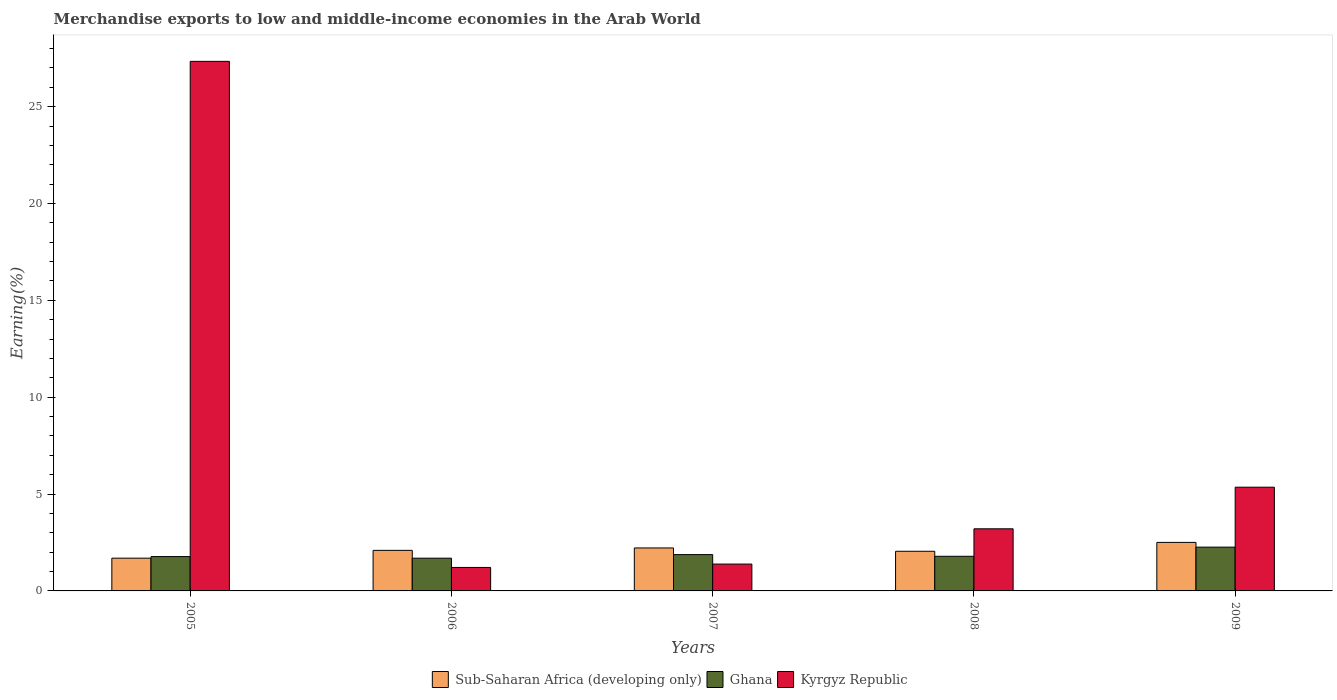How many different coloured bars are there?
Offer a terse response. 3. Are the number of bars per tick equal to the number of legend labels?
Offer a very short reply. Yes. Are the number of bars on each tick of the X-axis equal?
Give a very brief answer. Yes. How many bars are there on the 2nd tick from the left?
Your answer should be compact. 3. What is the percentage of amount earned from merchandise exports in Kyrgyz Republic in 2008?
Provide a succinct answer. 3.21. Across all years, what is the maximum percentage of amount earned from merchandise exports in Ghana?
Provide a succinct answer. 2.26. Across all years, what is the minimum percentage of amount earned from merchandise exports in Kyrgyz Republic?
Keep it short and to the point. 1.21. In which year was the percentage of amount earned from merchandise exports in Kyrgyz Republic maximum?
Your answer should be very brief. 2005. In which year was the percentage of amount earned from merchandise exports in Kyrgyz Republic minimum?
Offer a very short reply. 2006. What is the total percentage of amount earned from merchandise exports in Sub-Saharan Africa (developing only) in the graph?
Provide a succinct answer. 10.56. What is the difference between the percentage of amount earned from merchandise exports in Kyrgyz Republic in 2007 and that in 2009?
Your response must be concise. -3.97. What is the difference between the percentage of amount earned from merchandise exports in Sub-Saharan Africa (developing only) in 2008 and the percentage of amount earned from merchandise exports in Kyrgyz Republic in 2005?
Your answer should be compact. -25.29. What is the average percentage of amount earned from merchandise exports in Sub-Saharan Africa (developing only) per year?
Provide a short and direct response. 2.11. In the year 2006, what is the difference between the percentage of amount earned from merchandise exports in Sub-Saharan Africa (developing only) and percentage of amount earned from merchandise exports in Ghana?
Offer a terse response. 0.4. In how many years, is the percentage of amount earned from merchandise exports in Sub-Saharan Africa (developing only) greater than 8 %?
Provide a succinct answer. 0. What is the ratio of the percentage of amount earned from merchandise exports in Sub-Saharan Africa (developing only) in 2007 to that in 2009?
Offer a very short reply. 0.89. Is the difference between the percentage of amount earned from merchandise exports in Sub-Saharan Africa (developing only) in 2008 and 2009 greater than the difference between the percentage of amount earned from merchandise exports in Ghana in 2008 and 2009?
Your answer should be very brief. Yes. What is the difference between the highest and the second highest percentage of amount earned from merchandise exports in Ghana?
Keep it short and to the point. 0.39. What is the difference between the highest and the lowest percentage of amount earned from merchandise exports in Ghana?
Make the answer very short. 0.57. What does the 3rd bar from the left in 2006 represents?
Your answer should be very brief. Kyrgyz Republic. What does the 1st bar from the right in 2005 represents?
Offer a very short reply. Kyrgyz Republic. How many bars are there?
Ensure brevity in your answer.  15. Does the graph contain any zero values?
Provide a short and direct response. No. Does the graph contain grids?
Provide a succinct answer. No. Where does the legend appear in the graph?
Keep it short and to the point. Bottom center. How many legend labels are there?
Ensure brevity in your answer.  3. How are the legend labels stacked?
Offer a terse response. Horizontal. What is the title of the graph?
Your response must be concise. Merchandise exports to low and middle-income economies in the Arab World. What is the label or title of the X-axis?
Give a very brief answer. Years. What is the label or title of the Y-axis?
Offer a terse response. Earning(%). What is the Earning(%) of Sub-Saharan Africa (developing only) in 2005?
Offer a terse response. 1.69. What is the Earning(%) of Ghana in 2005?
Your answer should be compact. 1.77. What is the Earning(%) of Kyrgyz Republic in 2005?
Provide a succinct answer. 27.34. What is the Earning(%) of Sub-Saharan Africa (developing only) in 2006?
Offer a terse response. 2.09. What is the Earning(%) in Ghana in 2006?
Give a very brief answer. 1.69. What is the Earning(%) in Kyrgyz Republic in 2006?
Offer a very short reply. 1.21. What is the Earning(%) of Sub-Saharan Africa (developing only) in 2007?
Ensure brevity in your answer.  2.22. What is the Earning(%) in Ghana in 2007?
Offer a very short reply. 1.87. What is the Earning(%) of Kyrgyz Republic in 2007?
Provide a succinct answer. 1.39. What is the Earning(%) of Sub-Saharan Africa (developing only) in 2008?
Offer a terse response. 2.05. What is the Earning(%) in Ghana in 2008?
Provide a succinct answer. 1.79. What is the Earning(%) in Kyrgyz Republic in 2008?
Give a very brief answer. 3.21. What is the Earning(%) of Sub-Saharan Africa (developing only) in 2009?
Offer a very short reply. 2.51. What is the Earning(%) of Ghana in 2009?
Make the answer very short. 2.26. What is the Earning(%) of Kyrgyz Republic in 2009?
Your answer should be compact. 5.35. Across all years, what is the maximum Earning(%) in Sub-Saharan Africa (developing only)?
Provide a short and direct response. 2.51. Across all years, what is the maximum Earning(%) in Ghana?
Ensure brevity in your answer.  2.26. Across all years, what is the maximum Earning(%) of Kyrgyz Republic?
Provide a short and direct response. 27.34. Across all years, what is the minimum Earning(%) in Sub-Saharan Africa (developing only)?
Offer a terse response. 1.69. Across all years, what is the minimum Earning(%) of Ghana?
Make the answer very short. 1.69. Across all years, what is the minimum Earning(%) in Kyrgyz Republic?
Your response must be concise. 1.21. What is the total Earning(%) in Sub-Saharan Africa (developing only) in the graph?
Provide a short and direct response. 10.56. What is the total Earning(%) of Ghana in the graph?
Ensure brevity in your answer.  9.39. What is the total Earning(%) of Kyrgyz Republic in the graph?
Offer a terse response. 38.5. What is the difference between the Earning(%) in Sub-Saharan Africa (developing only) in 2005 and that in 2006?
Your response must be concise. -0.4. What is the difference between the Earning(%) in Ghana in 2005 and that in 2006?
Offer a very short reply. 0.08. What is the difference between the Earning(%) in Kyrgyz Republic in 2005 and that in 2006?
Ensure brevity in your answer.  26.13. What is the difference between the Earning(%) in Sub-Saharan Africa (developing only) in 2005 and that in 2007?
Keep it short and to the point. -0.53. What is the difference between the Earning(%) of Ghana in 2005 and that in 2007?
Offer a terse response. -0.1. What is the difference between the Earning(%) of Kyrgyz Republic in 2005 and that in 2007?
Provide a succinct answer. 25.95. What is the difference between the Earning(%) of Sub-Saharan Africa (developing only) in 2005 and that in 2008?
Your answer should be compact. -0.36. What is the difference between the Earning(%) in Ghana in 2005 and that in 2008?
Provide a short and direct response. -0.01. What is the difference between the Earning(%) of Kyrgyz Republic in 2005 and that in 2008?
Give a very brief answer. 24.13. What is the difference between the Earning(%) of Sub-Saharan Africa (developing only) in 2005 and that in 2009?
Provide a short and direct response. -0.81. What is the difference between the Earning(%) of Ghana in 2005 and that in 2009?
Make the answer very short. -0.49. What is the difference between the Earning(%) in Kyrgyz Republic in 2005 and that in 2009?
Offer a terse response. 21.98. What is the difference between the Earning(%) in Sub-Saharan Africa (developing only) in 2006 and that in 2007?
Your answer should be very brief. -0.13. What is the difference between the Earning(%) of Ghana in 2006 and that in 2007?
Offer a terse response. -0.18. What is the difference between the Earning(%) in Kyrgyz Republic in 2006 and that in 2007?
Provide a succinct answer. -0.17. What is the difference between the Earning(%) of Sub-Saharan Africa (developing only) in 2006 and that in 2008?
Keep it short and to the point. 0.05. What is the difference between the Earning(%) in Ghana in 2006 and that in 2008?
Give a very brief answer. -0.1. What is the difference between the Earning(%) in Kyrgyz Republic in 2006 and that in 2008?
Provide a succinct answer. -1.99. What is the difference between the Earning(%) in Sub-Saharan Africa (developing only) in 2006 and that in 2009?
Your answer should be compact. -0.41. What is the difference between the Earning(%) of Ghana in 2006 and that in 2009?
Give a very brief answer. -0.57. What is the difference between the Earning(%) in Kyrgyz Republic in 2006 and that in 2009?
Provide a succinct answer. -4.14. What is the difference between the Earning(%) of Sub-Saharan Africa (developing only) in 2007 and that in 2008?
Provide a short and direct response. 0.17. What is the difference between the Earning(%) of Ghana in 2007 and that in 2008?
Make the answer very short. 0.09. What is the difference between the Earning(%) in Kyrgyz Republic in 2007 and that in 2008?
Your answer should be compact. -1.82. What is the difference between the Earning(%) of Sub-Saharan Africa (developing only) in 2007 and that in 2009?
Provide a succinct answer. -0.29. What is the difference between the Earning(%) of Ghana in 2007 and that in 2009?
Provide a succinct answer. -0.39. What is the difference between the Earning(%) in Kyrgyz Republic in 2007 and that in 2009?
Your answer should be very brief. -3.97. What is the difference between the Earning(%) in Sub-Saharan Africa (developing only) in 2008 and that in 2009?
Keep it short and to the point. -0.46. What is the difference between the Earning(%) in Ghana in 2008 and that in 2009?
Keep it short and to the point. -0.47. What is the difference between the Earning(%) of Kyrgyz Republic in 2008 and that in 2009?
Give a very brief answer. -2.15. What is the difference between the Earning(%) of Sub-Saharan Africa (developing only) in 2005 and the Earning(%) of Ghana in 2006?
Ensure brevity in your answer.  0. What is the difference between the Earning(%) of Sub-Saharan Africa (developing only) in 2005 and the Earning(%) of Kyrgyz Republic in 2006?
Your answer should be compact. 0.48. What is the difference between the Earning(%) in Ghana in 2005 and the Earning(%) in Kyrgyz Republic in 2006?
Provide a short and direct response. 0.56. What is the difference between the Earning(%) in Sub-Saharan Africa (developing only) in 2005 and the Earning(%) in Ghana in 2007?
Keep it short and to the point. -0.18. What is the difference between the Earning(%) in Sub-Saharan Africa (developing only) in 2005 and the Earning(%) in Kyrgyz Republic in 2007?
Give a very brief answer. 0.31. What is the difference between the Earning(%) in Ghana in 2005 and the Earning(%) in Kyrgyz Republic in 2007?
Offer a very short reply. 0.39. What is the difference between the Earning(%) in Sub-Saharan Africa (developing only) in 2005 and the Earning(%) in Ghana in 2008?
Provide a succinct answer. -0.1. What is the difference between the Earning(%) in Sub-Saharan Africa (developing only) in 2005 and the Earning(%) in Kyrgyz Republic in 2008?
Provide a short and direct response. -1.52. What is the difference between the Earning(%) in Ghana in 2005 and the Earning(%) in Kyrgyz Republic in 2008?
Provide a succinct answer. -1.43. What is the difference between the Earning(%) in Sub-Saharan Africa (developing only) in 2005 and the Earning(%) in Ghana in 2009?
Provide a succinct answer. -0.57. What is the difference between the Earning(%) of Sub-Saharan Africa (developing only) in 2005 and the Earning(%) of Kyrgyz Republic in 2009?
Offer a very short reply. -3.66. What is the difference between the Earning(%) in Ghana in 2005 and the Earning(%) in Kyrgyz Republic in 2009?
Ensure brevity in your answer.  -3.58. What is the difference between the Earning(%) in Sub-Saharan Africa (developing only) in 2006 and the Earning(%) in Ghana in 2007?
Give a very brief answer. 0.22. What is the difference between the Earning(%) of Sub-Saharan Africa (developing only) in 2006 and the Earning(%) of Kyrgyz Republic in 2007?
Your answer should be very brief. 0.71. What is the difference between the Earning(%) in Ghana in 2006 and the Earning(%) in Kyrgyz Republic in 2007?
Your response must be concise. 0.3. What is the difference between the Earning(%) of Sub-Saharan Africa (developing only) in 2006 and the Earning(%) of Ghana in 2008?
Ensure brevity in your answer.  0.31. What is the difference between the Earning(%) of Sub-Saharan Africa (developing only) in 2006 and the Earning(%) of Kyrgyz Republic in 2008?
Offer a very short reply. -1.11. What is the difference between the Earning(%) of Ghana in 2006 and the Earning(%) of Kyrgyz Republic in 2008?
Provide a succinct answer. -1.52. What is the difference between the Earning(%) of Sub-Saharan Africa (developing only) in 2006 and the Earning(%) of Ghana in 2009?
Your response must be concise. -0.17. What is the difference between the Earning(%) of Sub-Saharan Africa (developing only) in 2006 and the Earning(%) of Kyrgyz Republic in 2009?
Ensure brevity in your answer.  -3.26. What is the difference between the Earning(%) of Ghana in 2006 and the Earning(%) of Kyrgyz Republic in 2009?
Make the answer very short. -3.66. What is the difference between the Earning(%) of Sub-Saharan Africa (developing only) in 2007 and the Earning(%) of Ghana in 2008?
Provide a succinct answer. 0.43. What is the difference between the Earning(%) in Sub-Saharan Africa (developing only) in 2007 and the Earning(%) in Kyrgyz Republic in 2008?
Provide a succinct answer. -0.99. What is the difference between the Earning(%) of Ghana in 2007 and the Earning(%) of Kyrgyz Republic in 2008?
Keep it short and to the point. -1.33. What is the difference between the Earning(%) in Sub-Saharan Africa (developing only) in 2007 and the Earning(%) in Ghana in 2009?
Give a very brief answer. -0.04. What is the difference between the Earning(%) in Sub-Saharan Africa (developing only) in 2007 and the Earning(%) in Kyrgyz Republic in 2009?
Provide a succinct answer. -3.14. What is the difference between the Earning(%) of Ghana in 2007 and the Earning(%) of Kyrgyz Republic in 2009?
Provide a succinct answer. -3.48. What is the difference between the Earning(%) in Sub-Saharan Africa (developing only) in 2008 and the Earning(%) in Ghana in 2009?
Offer a very short reply. -0.21. What is the difference between the Earning(%) of Sub-Saharan Africa (developing only) in 2008 and the Earning(%) of Kyrgyz Republic in 2009?
Provide a succinct answer. -3.31. What is the difference between the Earning(%) of Ghana in 2008 and the Earning(%) of Kyrgyz Republic in 2009?
Keep it short and to the point. -3.57. What is the average Earning(%) in Sub-Saharan Africa (developing only) per year?
Offer a very short reply. 2.11. What is the average Earning(%) of Ghana per year?
Offer a terse response. 1.88. What is the average Earning(%) in Kyrgyz Republic per year?
Your answer should be very brief. 7.7. In the year 2005, what is the difference between the Earning(%) in Sub-Saharan Africa (developing only) and Earning(%) in Ghana?
Your answer should be very brief. -0.08. In the year 2005, what is the difference between the Earning(%) in Sub-Saharan Africa (developing only) and Earning(%) in Kyrgyz Republic?
Offer a terse response. -25.65. In the year 2005, what is the difference between the Earning(%) of Ghana and Earning(%) of Kyrgyz Republic?
Offer a very short reply. -25.57. In the year 2006, what is the difference between the Earning(%) of Sub-Saharan Africa (developing only) and Earning(%) of Ghana?
Make the answer very short. 0.4. In the year 2006, what is the difference between the Earning(%) of Sub-Saharan Africa (developing only) and Earning(%) of Kyrgyz Republic?
Provide a succinct answer. 0.88. In the year 2006, what is the difference between the Earning(%) of Ghana and Earning(%) of Kyrgyz Republic?
Your answer should be very brief. 0.48. In the year 2007, what is the difference between the Earning(%) in Sub-Saharan Africa (developing only) and Earning(%) in Ghana?
Your answer should be very brief. 0.34. In the year 2007, what is the difference between the Earning(%) in Sub-Saharan Africa (developing only) and Earning(%) in Kyrgyz Republic?
Your answer should be very brief. 0.83. In the year 2007, what is the difference between the Earning(%) of Ghana and Earning(%) of Kyrgyz Republic?
Your answer should be compact. 0.49. In the year 2008, what is the difference between the Earning(%) of Sub-Saharan Africa (developing only) and Earning(%) of Ghana?
Your response must be concise. 0.26. In the year 2008, what is the difference between the Earning(%) in Sub-Saharan Africa (developing only) and Earning(%) in Kyrgyz Republic?
Make the answer very short. -1.16. In the year 2008, what is the difference between the Earning(%) in Ghana and Earning(%) in Kyrgyz Republic?
Make the answer very short. -1.42. In the year 2009, what is the difference between the Earning(%) of Sub-Saharan Africa (developing only) and Earning(%) of Ghana?
Make the answer very short. 0.24. In the year 2009, what is the difference between the Earning(%) of Sub-Saharan Africa (developing only) and Earning(%) of Kyrgyz Republic?
Keep it short and to the point. -2.85. In the year 2009, what is the difference between the Earning(%) of Ghana and Earning(%) of Kyrgyz Republic?
Your answer should be very brief. -3.09. What is the ratio of the Earning(%) of Sub-Saharan Africa (developing only) in 2005 to that in 2006?
Make the answer very short. 0.81. What is the ratio of the Earning(%) of Ghana in 2005 to that in 2006?
Offer a terse response. 1.05. What is the ratio of the Earning(%) of Kyrgyz Republic in 2005 to that in 2006?
Give a very brief answer. 22.55. What is the ratio of the Earning(%) in Sub-Saharan Africa (developing only) in 2005 to that in 2007?
Ensure brevity in your answer.  0.76. What is the ratio of the Earning(%) of Ghana in 2005 to that in 2007?
Give a very brief answer. 0.95. What is the ratio of the Earning(%) of Kyrgyz Republic in 2005 to that in 2007?
Keep it short and to the point. 19.73. What is the ratio of the Earning(%) of Sub-Saharan Africa (developing only) in 2005 to that in 2008?
Give a very brief answer. 0.83. What is the ratio of the Earning(%) in Kyrgyz Republic in 2005 to that in 2008?
Provide a succinct answer. 8.52. What is the ratio of the Earning(%) in Sub-Saharan Africa (developing only) in 2005 to that in 2009?
Your answer should be compact. 0.68. What is the ratio of the Earning(%) of Ghana in 2005 to that in 2009?
Your response must be concise. 0.78. What is the ratio of the Earning(%) in Kyrgyz Republic in 2005 to that in 2009?
Offer a terse response. 5.11. What is the ratio of the Earning(%) of Sub-Saharan Africa (developing only) in 2006 to that in 2007?
Keep it short and to the point. 0.94. What is the ratio of the Earning(%) of Ghana in 2006 to that in 2007?
Make the answer very short. 0.9. What is the ratio of the Earning(%) in Kyrgyz Republic in 2006 to that in 2007?
Offer a terse response. 0.87. What is the ratio of the Earning(%) of Sub-Saharan Africa (developing only) in 2006 to that in 2008?
Your answer should be compact. 1.02. What is the ratio of the Earning(%) in Ghana in 2006 to that in 2008?
Ensure brevity in your answer.  0.95. What is the ratio of the Earning(%) of Kyrgyz Republic in 2006 to that in 2008?
Make the answer very short. 0.38. What is the ratio of the Earning(%) in Sub-Saharan Africa (developing only) in 2006 to that in 2009?
Keep it short and to the point. 0.84. What is the ratio of the Earning(%) of Ghana in 2006 to that in 2009?
Your answer should be compact. 0.75. What is the ratio of the Earning(%) in Kyrgyz Republic in 2006 to that in 2009?
Provide a short and direct response. 0.23. What is the ratio of the Earning(%) in Sub-Saharan Africa (developing only) in 2007 to that in 2008?
Your response must be concise. 1.08. What is the ratio of the Earning(%) of Ghana in 2007 to that in 2008?
Your answer should be compact. 1.05. What is the ratio of the Earning(%) in Kyrgyz Republic in 2007 to that in 2008?
Your answer should be very brief. 0.43. What is the ratio of the Earning(%) of Sub-Saharan Africa (developing only) in 2007 to that in 2009?
Your response must be concise. 0.89. What is the ratio of the Earning(%) in Ghana in 2007 to that in 2009?
Make the answer very short. 0.83. What is the ratio of the Earning(%) of Kyrgyz Republic in 2007 to that in 2009?
Your answer should be very brief. 0.26. What is the ratio of the Earning(%) of Sub-Saharan Africa (developing only) in 2008 to that in 2009?
Provide a succinct answer. 0.82. What is the ratio of the Earning(%) in Ghana in 2008 to that in 2009?
Your response must be concise. 0.79. What is the ratio of the Earning(%) of Kyrgyz Republic in 2008 to that in 2009?
Offer a very short reply. 0.6. What is the difference between the highest and the second highest Earning(%) in Sub-Saharan Africa (developing only)?
Offer a terse response. 0.29. What is the difference between the highest and the second highest Earning(%) in Ghana?
Your response must be concise. 0.39. What is the difference between the highest and the second highest Earning(%) in Kyrgyz Republic?
Offer a terse response. 21.98. What is the difference between the highest and the lowest Earning(%) of Sub-Saharan Africa (developing only)?
Your answer should be very brief. 0.81. What is the difference between the highest and the lowest Earning(%) in Ghana?
Provide a short and direct response. 0.57. What is the difference between the highest and the lowest Earning(%) of Kyrgyz Republic?
Your answer should be compact. 26.13. 